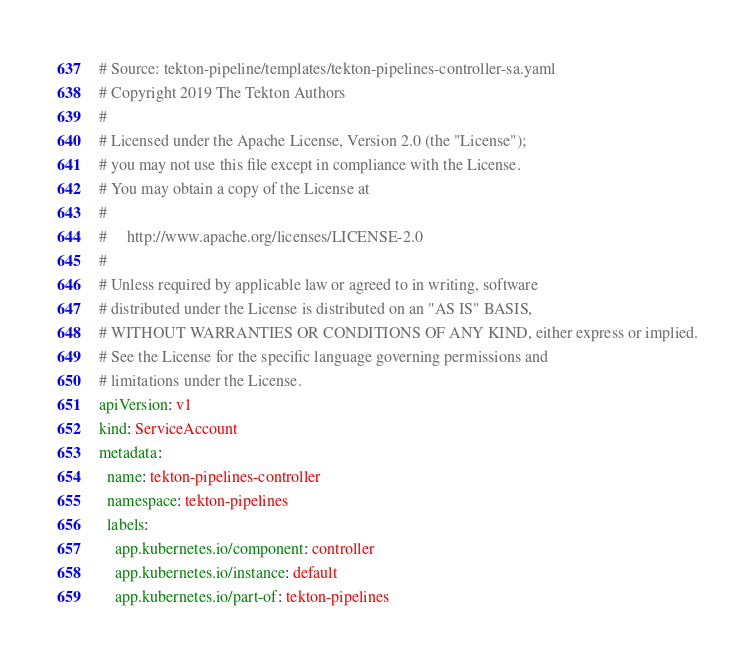Convert code to text. <code><loc_0><loc_0><loc_500><loc_500><_YAML_># Source: tekton-pipeline/templates/tekton-pipelines-controller-sa.yaml
# Copyright 2019 The Tekton Authors
#
# Licensed under the Apache License, Version 2.0 (the "License");
# you may not use this file except in compliance with the License.
# You may obtain a copy of the License at
#
#     http://www.apache.org/licenses/LICENSE-2.0
#
# Unless required by applicable law or agreed to in writing, software
# distributed under the License is distributed on an "AS IS" BASIS,
# WITHOUT WARRANTIES OR CONDITIONS OF ANY KIND, either express or implied.
# See the License for the specific language governing permissions and
# limitations under the License.
apiVersion: v1
kind: ServiceAccount
metadata:
  name: tekton-pipelines-controller
  namespace: tekton-pipelines
  labels:
    app.kubernetes.io/component: controller
    app.kubernetes.io/instance: default
    app.kubernetes.io/part-of: tekton-pipelines
</code> 